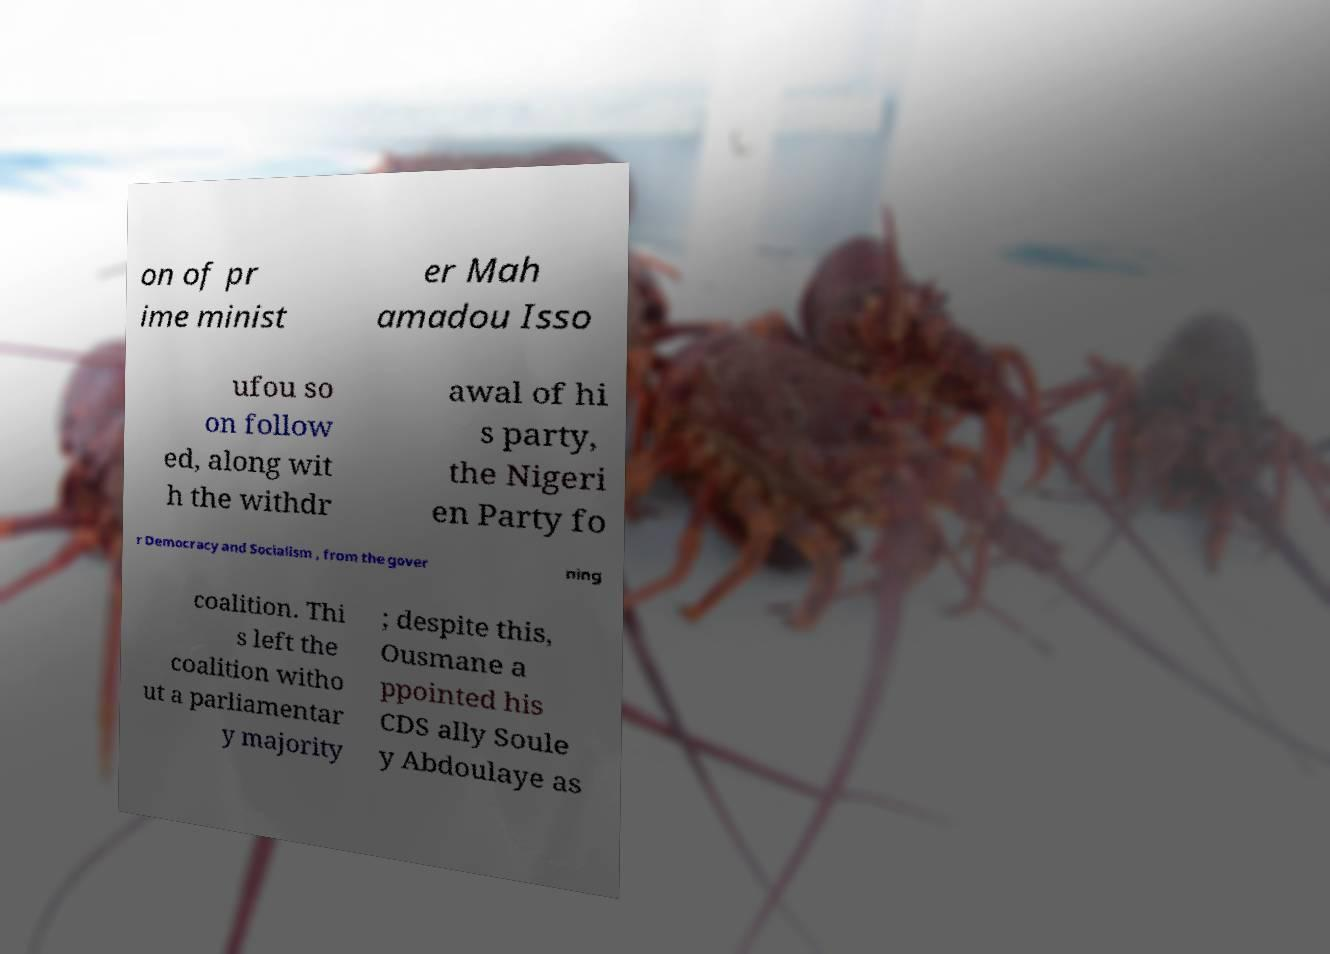What messages or text are displayed in this image? I need them in a readable, typed format. on of pr ime minist er Mah amadou Isso ufou so on follow ed, along wit h the withdr awal of hi s party, the Nigeri en Party fo r Democracy and Socialism , from the gover ning coalition. Thi s left the coalition witho ut a parliamentar y majority ; despite this, Ousmane a ppointed his CDS ally Soule y Abdoulaye as 